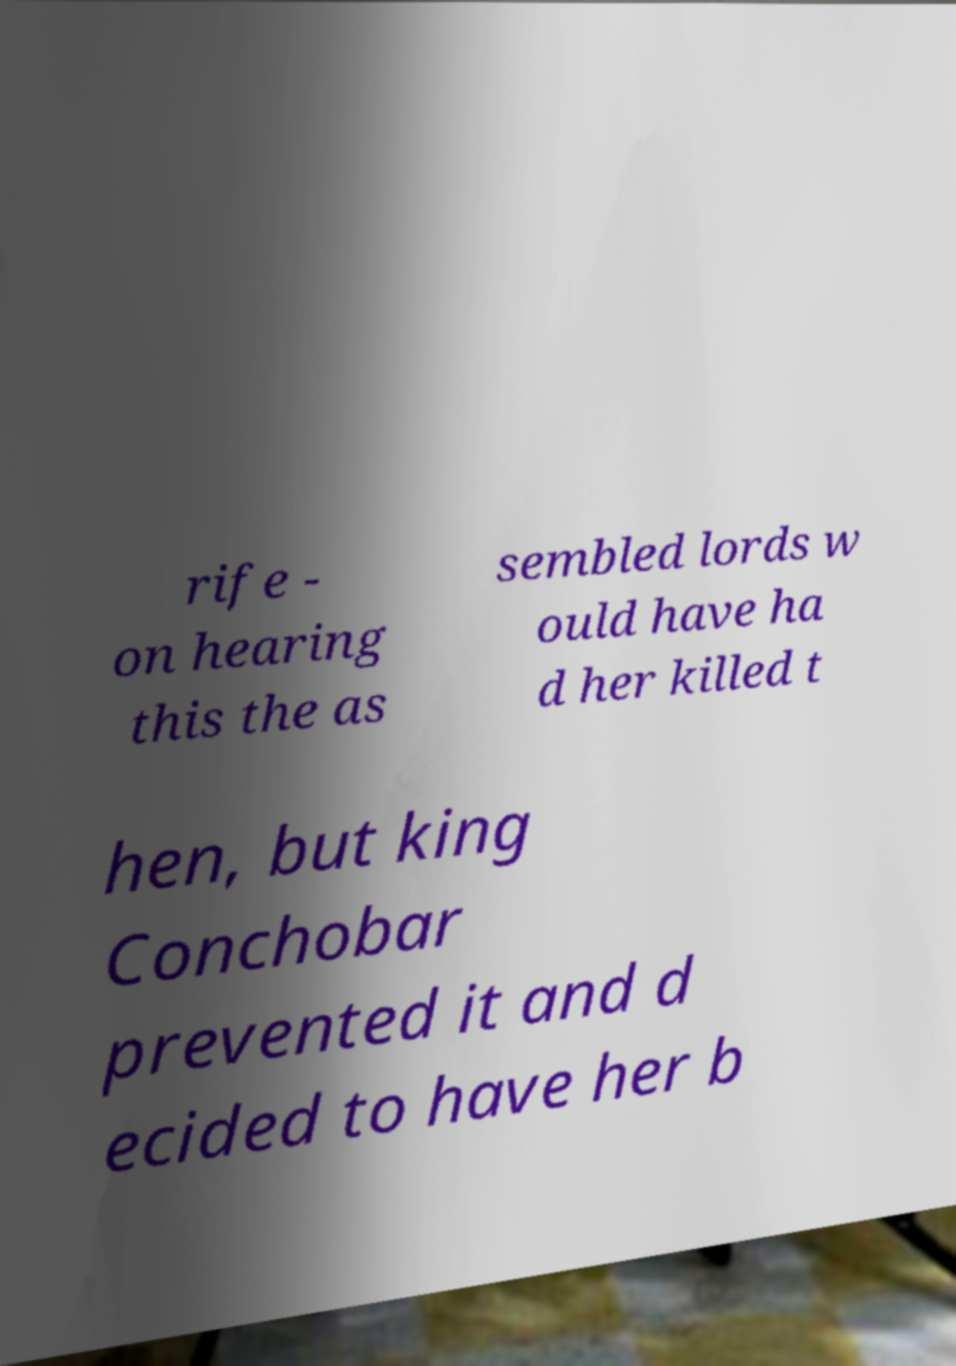Please identify and transcribe the text found in this image. rife - on hearing this the as sembled lords w ould have ha d her killed t hen, but king Conchobar prevented it and d ecided to have her b 